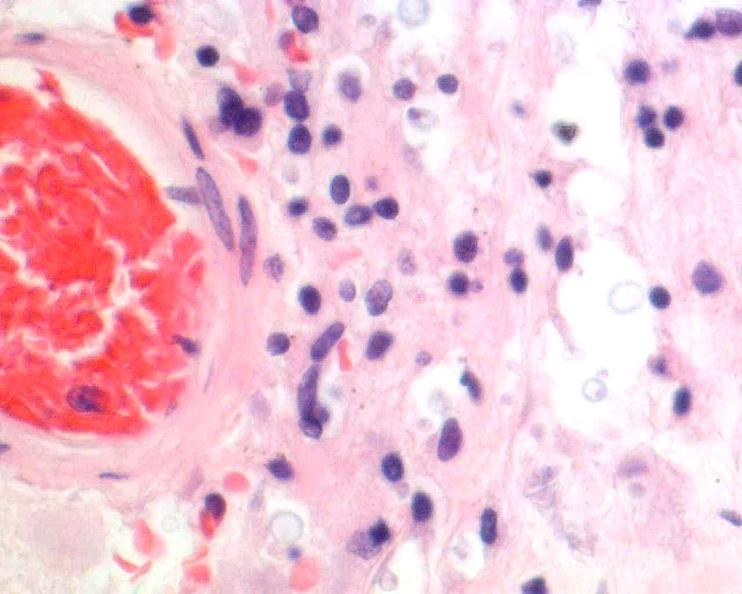does stillborn cord around neck show brain, cryptococcal meningitis, he?
Answer the question using a single word or phrase. No 